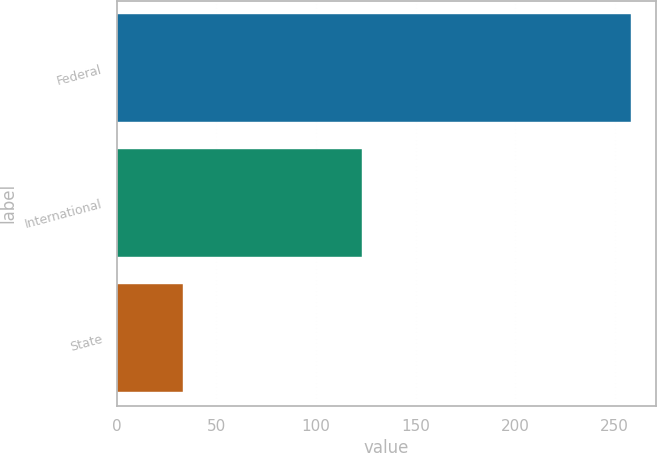Convert chart to OTSL. <chart><loc_0><loc_0><loc_500><loc_500><bar_chart><fcel>Federal<fcel>International<fcel>State<nl><fcel>258<fcel>123<fcel>33<nl></chart> 